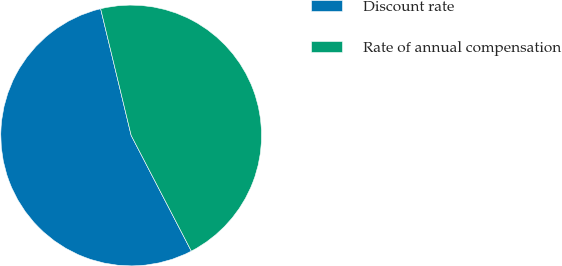Convert chart. <chart><loc_0><loc_0><loc_500><loc_500><pie_chart><fcel>Discount rate<fcel>Rate of annual compensation<nl><fcel>53.87%<fcel>46.13%<nl></chart> 